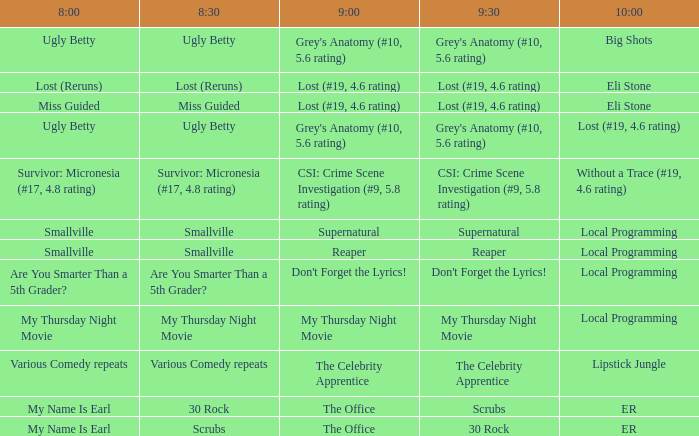What is at 8:00 when at 8:30 it is my thursday night movie? My Thursday Night Movie. 